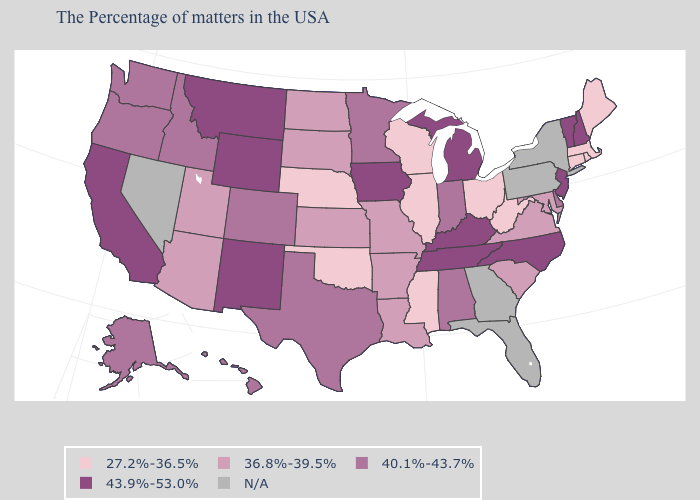What is the lowest value in the USA?
Concise answer only. 27.2%-36.5%. Name the states that have a value in the range 40.1%-43.7%?
Quick response, please. Delaware, Indiana, Alabama, Minnesota, Texas, Colorado, Idaho, Washington, Oregon, Alaska, Hawaii. What is the value of Hawaii?
Write a very short answer. 40.1%-43.7%. Which states have the highest value in the USA?
Be succinct. New Hampshire, Vermont, New Jersey, North Carolina, Michigan, Kentucky, Tennessee, Iowa, Wyoming, New Mexico, Montana, California. Name the states that have a value in the range 40.1%-43.7%?
Answer briefly. Delaware, Indiana, Alabama, Minnesota, Texas, Colorado, Idaho, Washington, Oregon, Alaska, Hawaii. What is the value of South Carolina?
Be succinct. 36.8%-39.5%. What is the lowest value in the West?
Be succinct. 36.8%-39.5%. Among the states that border Georgia , which have the lowest value?
Keep it brief. South Carolina. Name the states that have a value in the range 40.1%-43.7%?
Concise answer only. Delaware, Indiana, Alabama, Minnesota, Texas, Colorado, Idaho, Washington, Oregon, Alaska, Hawaii. Is the legend a continuous bar?
Be succinct. No. Name the states that have a value in the range 40.1%-43.7%?
Give a very brief answer. Delaware, Indiana, Alabama, Minnesota, Texas, Colorado, Idaho, Washington, Oregon, Alaska, Hawaii. Does Ohio have the lowest value in the MidWest?
Keep it brief. Yes. Which states hav the highest value in the MidWest?
Be succinct. Michigan, Iowa. 